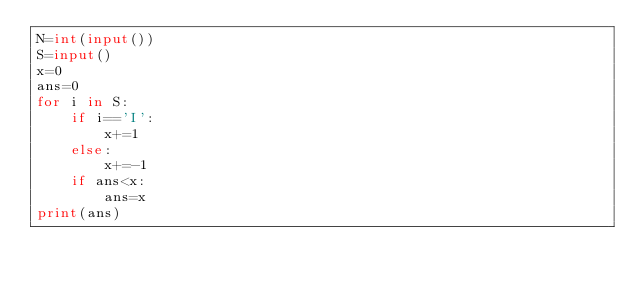Convert code to text. <code><loc_0><loc_0><loc_500><loc_500><_Python_>N=int(input())
S=input()
x=0
ans=0
for i in S:
    if i=='I':
        x+=1
    else:
        x+=-1
    if ans<x:
        ans=x
print(ans)
</code> 